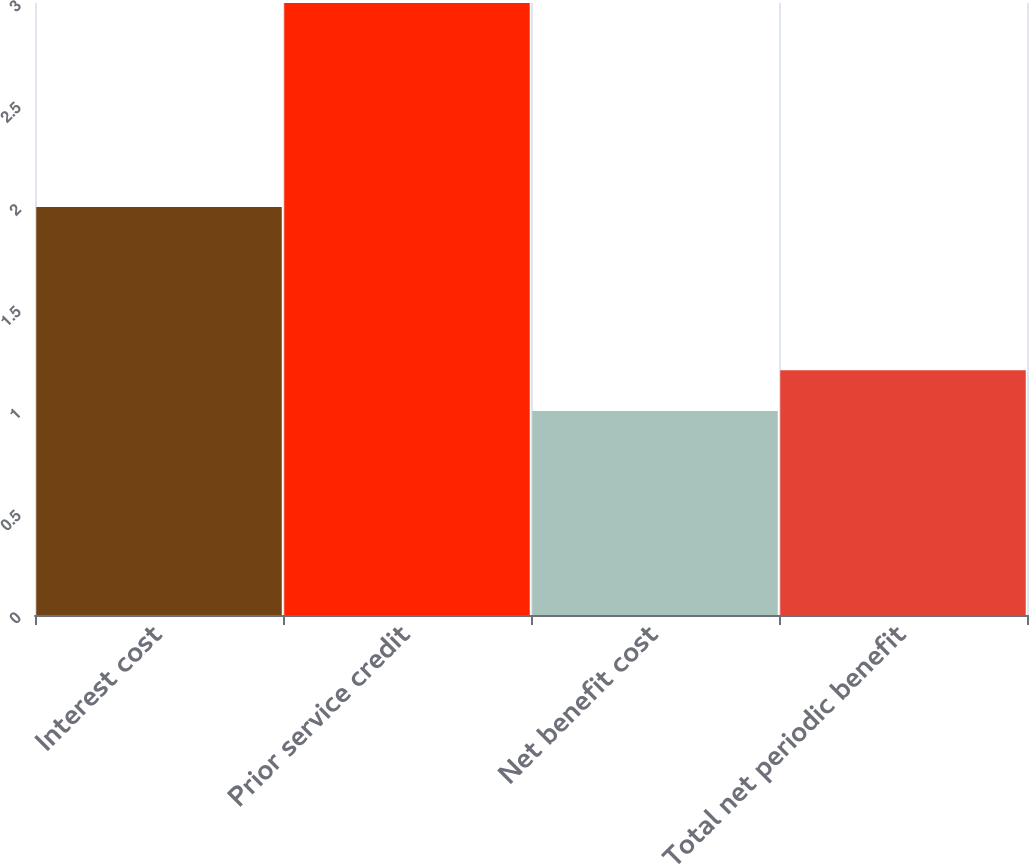<chart> <loc_0><loc_0><loc_500><loc_500><bar_chart><fcel>Interest cost<fcel>Prior service credit<fcel>Net benefit cost<fcel>Total net periodic benefit<nl><fcel>2<fcel>3<fcel>1<fcel>1.2<nl></chart> 